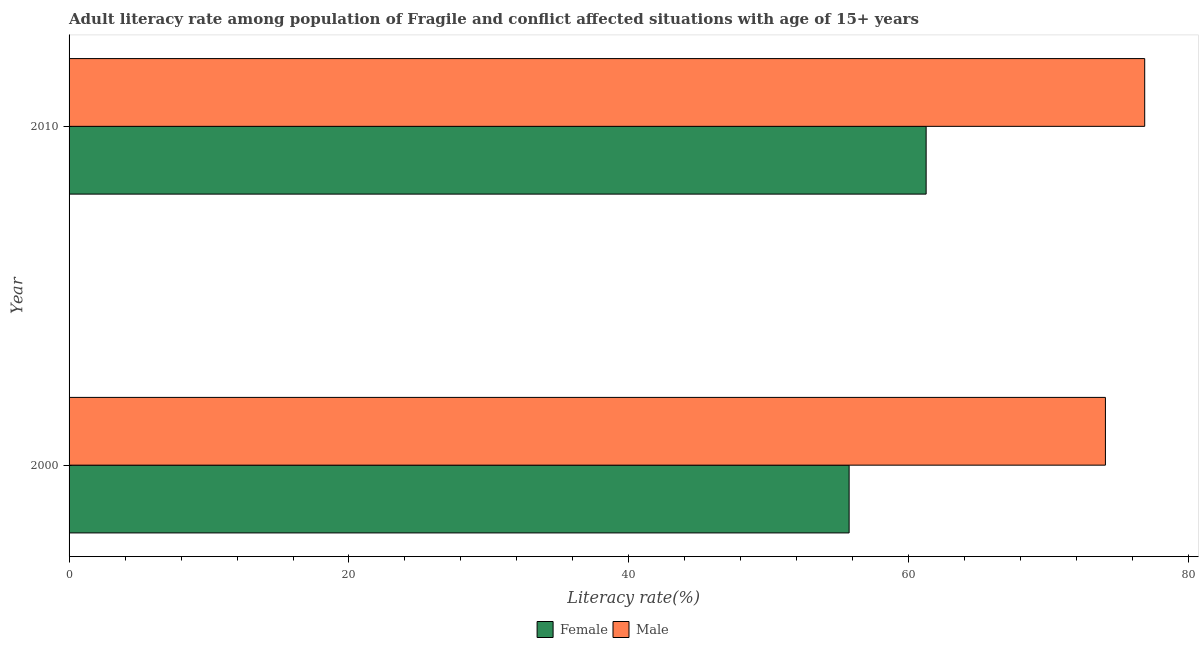What is the male adult literacy rate in 2000?
Provide a short and direct response. 74.05. Across all years, what is the maximum female adult literacy rate?
Ensure brevity in your answer.  61.24. Across all years, what is the minimum male adult literacy rate?
Provide a short and direct response. 74.05. In which year was the male adult literacy rate minimum?
Your answer should be very brief. 2000. What is the total male adult literacy rate in the graph?
Your response must be concise. 150.9. What is the difference between the male adult literacy rate in 2000 and that in 2010?
Your response must be concise. -2.81. What is the difference between the female adult literacy rate in 2010 and the male adult literacy rate in 2000?
Make the answer very short. -12.81. What is the average male adult literacy rate per year?
Give a very brief answer. 75.45. In the year 2010, what is the difference between the female adult literacy rate and male adult literacy rate?
Provide a short and direct response. -15.62. In how many years, is the male adult literacy rate greater than 64 %?
Ensure brevity in your answer.  2. What is the ratio of the female adult literacy rate in 2000 to that in 2010?
Your answer should be very brief. 0.91. In how many years, is the male adult literacy rate greater than the average male adult literacy rate taken over all years?
Keep it short and to the point. 1. What does the 1st bar from the bottom in 2000 represents?
Give a very brief answer. Female. Where does the legend appear in the graph?
Offer a very short reply. Bottom center. How many legend labels are there?
Provide a short and direct response. 2. What is the title of the graph?
Ensure brevity in your answer.  Adult literacy rate among population of Fragile and conflict affected situations with age of 15+ years. Does "Gasoline" appear as one of the legend labels in the graph?
Provide a short and direct response. No. What is the label or title of the X-axis?
Make the answer very short. Literacy rate(%). What is the Literacy rate(%) in Female in 2000?
Keep it short and to the point. 55.74. What is the Literacy rate(%) of Male in 2000?
Make the answer very short. 74.05. What is the Literacy rate(%) of Female in 2010?
Make the answer very short. 61.24. What is the Literacy rate(%) of Male in 2010?
Offer a very short reply. 76.86. Across all years, what is the maximum Literacy rate(%) in Female?
Give a very brief answer. 61.24. Across all years, what is the maximum Literacy rate(%) of Male?
Your response must be concise. 76.86. Across all years, what is the minimum Literacy rate(%) of Female?
Your response must be concise. 55.74. Across all years, what is the minimum Literacy rate(%) in Male?
Give a very brief answer. 74.05. What is the total Literacy rate(%) in Female in the graph?
Your answer should be compact. 116.97. What is the total Literacy rate(%) in Male in the graph?
Make the answer very short. 150.9. What is the difference between the Literacy rate(%) in Female in 2000 and that in 2010?
Ensure brevity in your answer.  -5.5. What is the difference between the Literacy rate(%) of Male in 2000 and that in 2010?
Your answer should be very brief. -2.81. What is the difference between the Literacy rate(%) of Female in 2000 and the Literacy rate(%) of Male in 2010?
Offer a very short reply. -21.12. What is the average Literacy rate(%) in Female per year?
Provide a succinct answer. 58.49. What is the average Literacy rate(%) of Male per year?
Your answer should be very brief. 75.45. In the year 2000, what is the difference between the Literacy rate(%) in Female and Literacy rate(%) in Male?
Ensure brevity in your answer.  -18.31. In the year 2010, what is the difference between the Literacy rate(%) of Female and Literacy rate(%) of Male?
Your answer should be compact. -15.62. What is the ratio of the Literacy rate(%) of Female in 2000 to that in 2010?
Your answer should be very brief. 0.91. What is the ratio of the Literacy rate(%) of Male in 2000 to that in 2010?
Offer a terse response. 0.96. What is the difference between the highest and the second highest Literacy rate(%) of Female?
Keep it short and to the point. 5.5. What is the difference between the highest and the second highest Literacy rate(%) of Male?
Ensure brevity in your answer.  2.81. What is the difference between the highest and the lowest Literacy rate(%) in Female?
Your answer should be compact. 5.5. What is the difference between the highest and the lowest Literacy rate(%) in Male?
Provide a succinct answer. 2.81. 